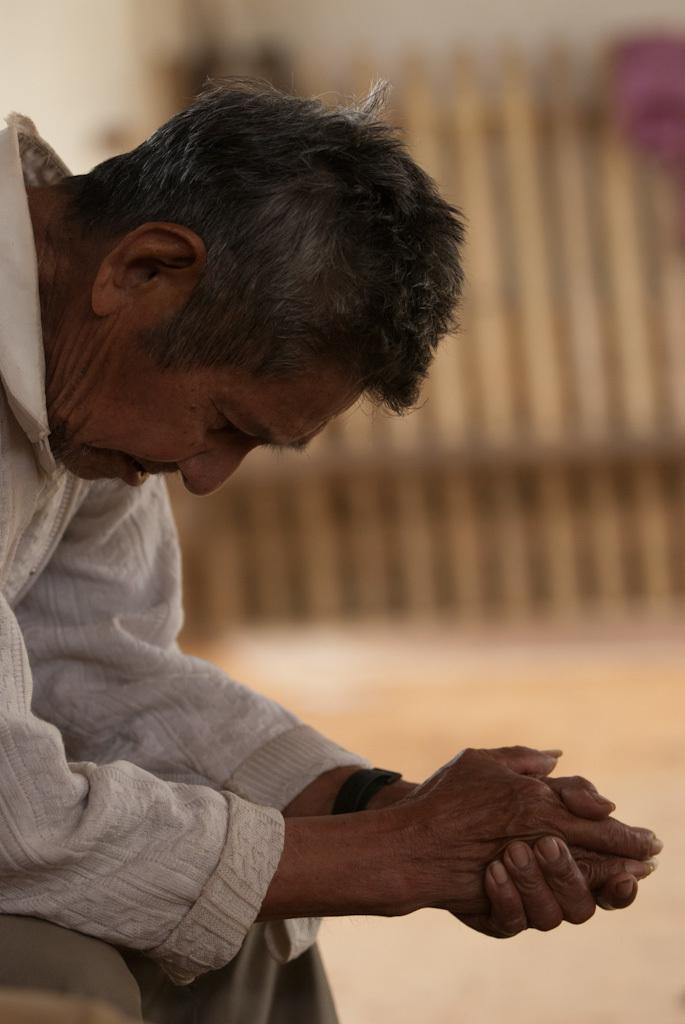What is present in the image? There is a person in the image. Can you describe the person's attire? The person is wearing a wrist watch. What type of ray can be seen swimming in the image? There is no ray present in the image; it only features a person wearing a wrist watch. 